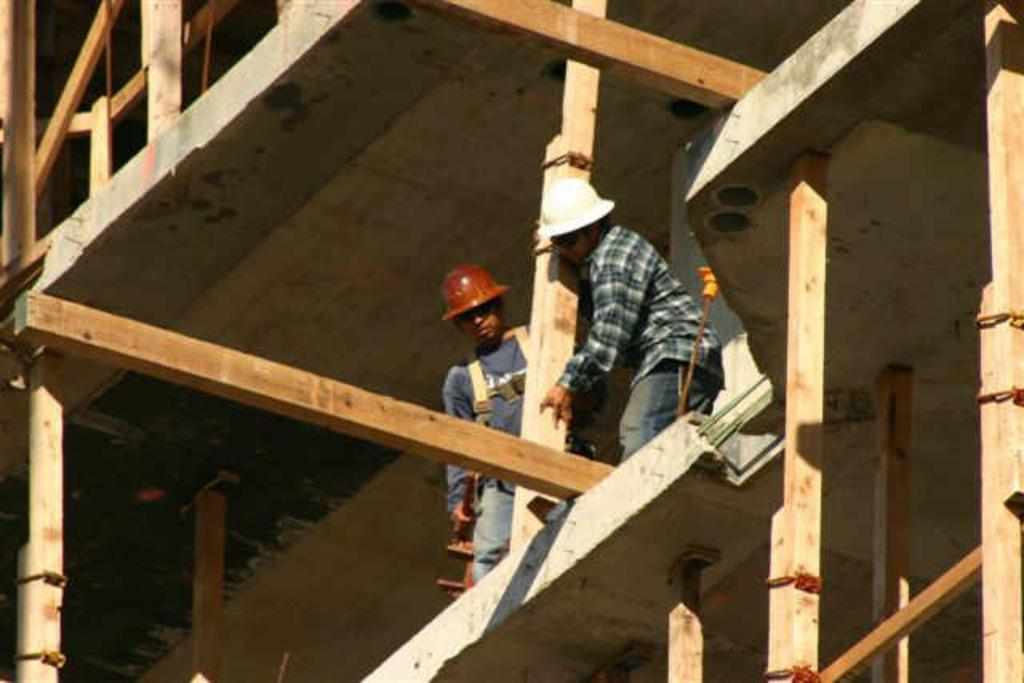What is the main subject of the image? The main subject of the image is a building under construction. How many people are present in the image? Two people are present in the image. What are the people doing in the image? One person is holding a pillar, and another person is holding an object in his hand. What type of cake is being served at the construction site in the image? There is no cake present in the image; it features a building under construction and two people holding objects. 